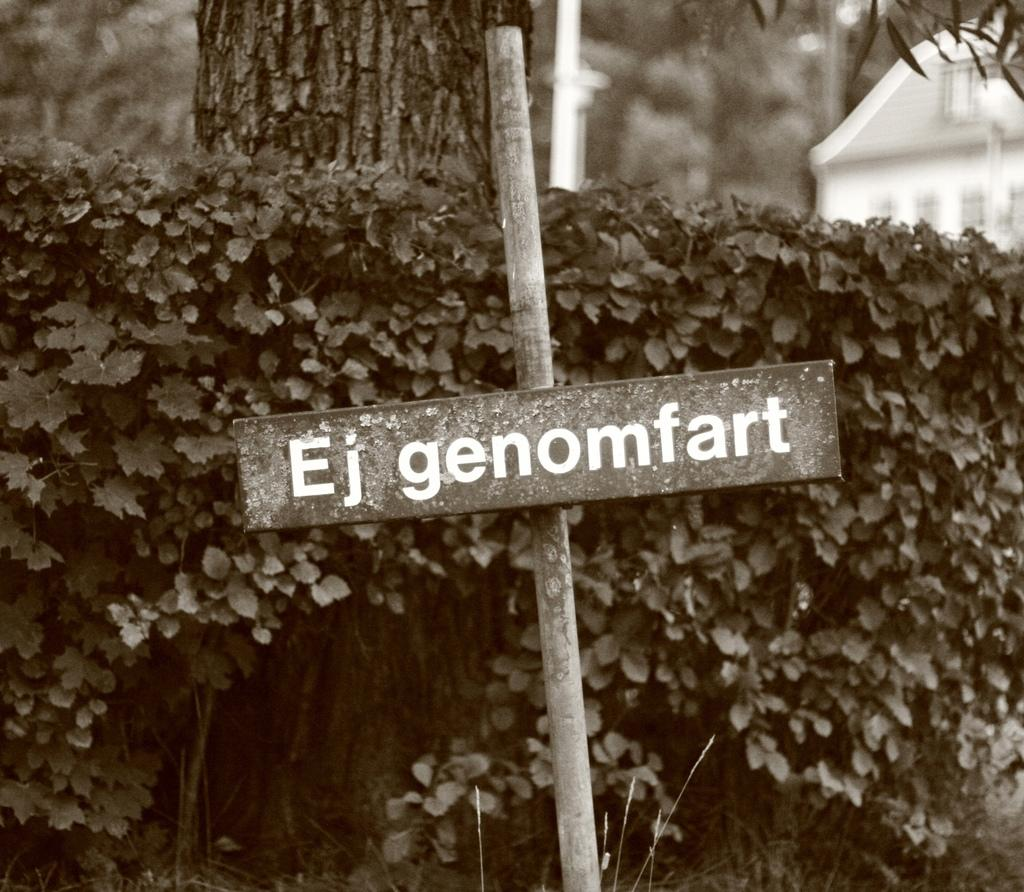What is written on in the image? There is written text on a board in the image. What object is made of wood and visible in the image? There is a wooden stick in the image. What type of vegetation can be seen in the image? There are plants and trees in the image. What type of structure is visible in the background of the image? There is a house in the background of the image. What type of sock is hanging on the tree in the image? There is no sock present in the image; it features written text on a board, a wooden stick, plants, trees, and a house in the background. Can you describe the type of grass growing in the image? There is no mention of grass in the provided facts, so we cannot describe its type. 